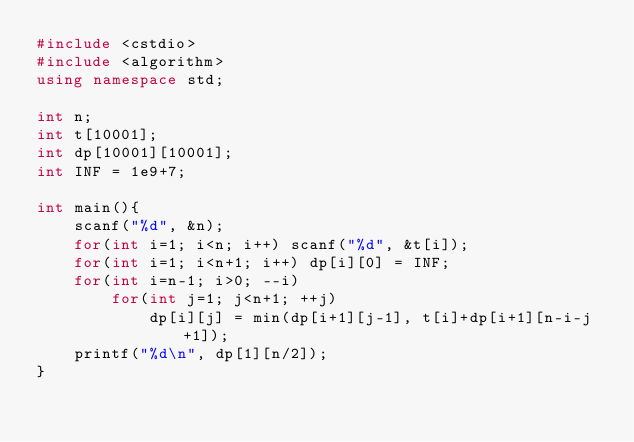Convert code to text. <code><loc_0><loc_0><loc_500><loc_500><_C++_>#include <cstdio>
#include <algorithm>
using namespace std;

int n;
int t[10001];
int dp[10001][10001];
int INF = 1e9+7;

int main(){
	scanf("%d", &n);
	for(int i=1; i<n; i++) scanf("%d", &t[i]);
	for(int i=1; i<n+1; i++) dp[i][0] = INF;
	for(int i=n-1; i>0; --i)
		for(int j=1; j<n+1; ++j)
			dp[i][j] = min(dp[i+1][j-1], t[i]+dp[i+1][n-i-j+1]);
	printf("%d\n", dp[1][n/2]);
}</code> 